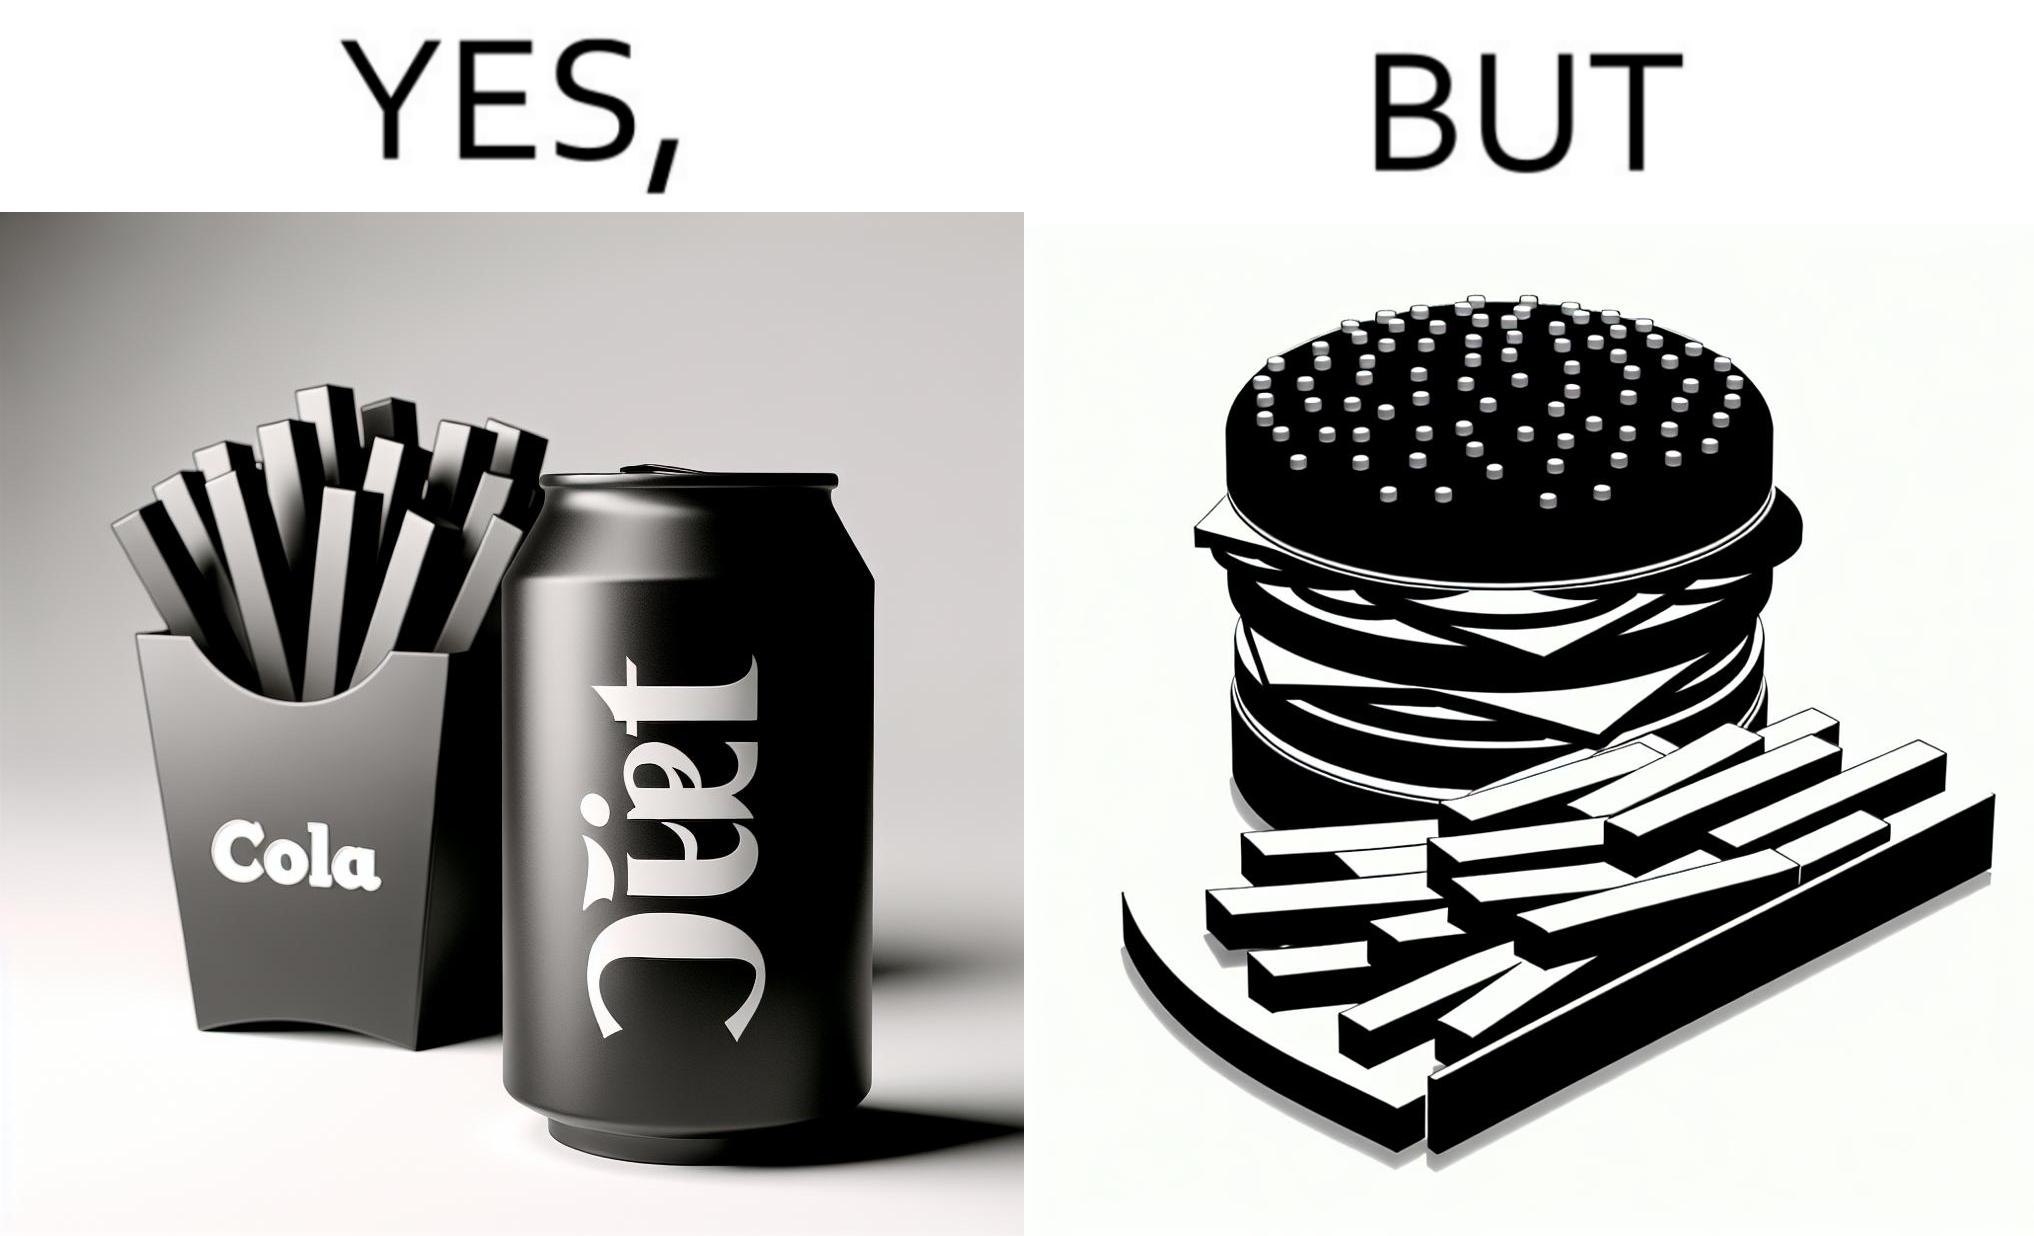What is the satirical meaning behind this image? The image is ironic, because on one hand the person is consuming diet cola suggesting low on sugar as per label meaning the person is health-conscious but on the other hand the same one is having huge size burger with french fries which suggests the person to be health-ignorant 